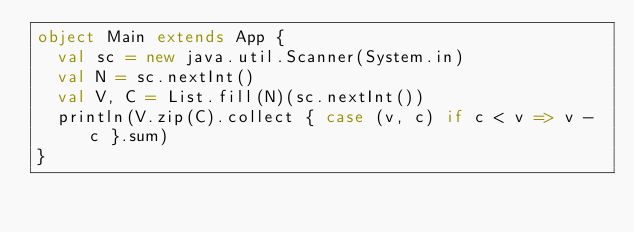<code> <loc_0><loc_0><loc_500><loc_500><_Scala_>object Main extends App {
  val sc = new java.util.Scanner(System.in)
  val N = sc.nextInt()
  val V, C = List.fill(N)(sc.nextInt())
  println(V.zip(C).collect { case (v, c) if c < v => v - c }.sum)
}
</code> 